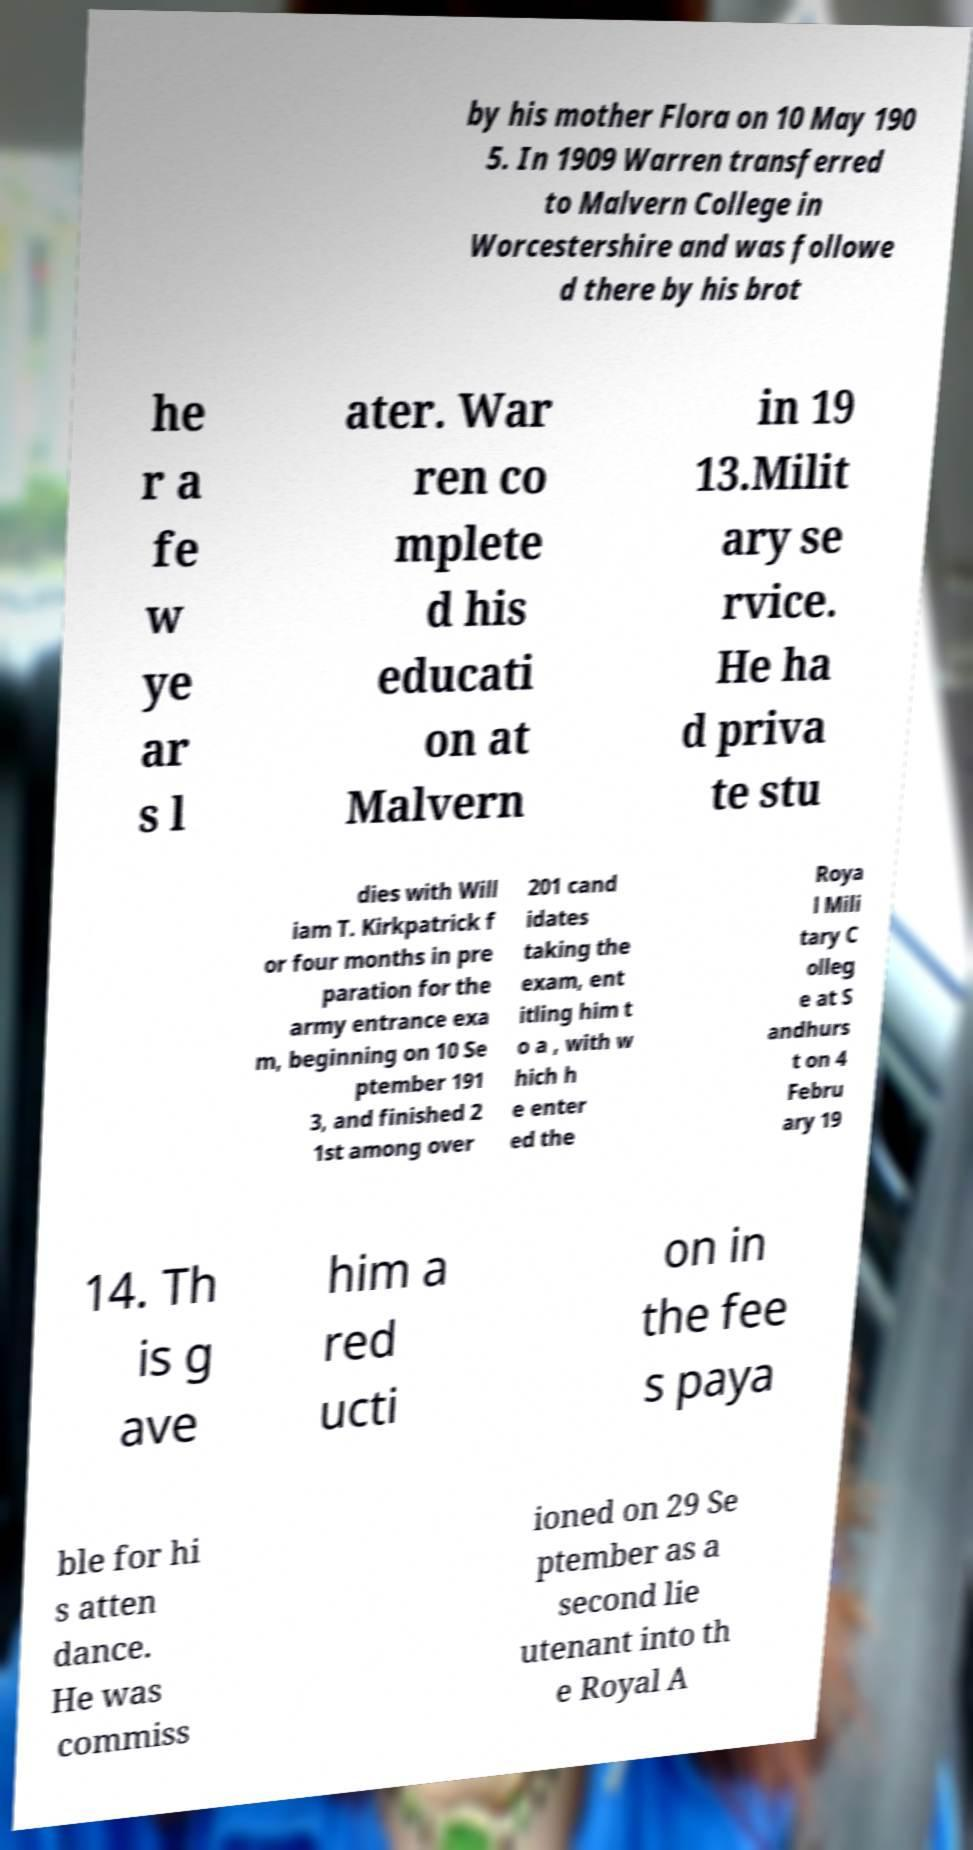There's text embedded in this image that I need extracted. Can you transcribe it verbatim? by his mother Flora on 10 May 190 5. In 1909 Warren transferred to Malvern College in Worcestershire and was followe d there by his brot he r a fe w ye ar s l ater. War ren co mplete d his educati on at Malvern in 19 13.Milit ary se rvice. He ha d priva te stu dies with Will iam T. Kirkpatrick f or four months in pre paration for the army entrance exa m, beginning on 10 Se ptember 191 3, and finished 2 1st among over 201 cand idates taking the exam, ent itling him t o a , with w hich h e enter ed the Roya l Mili tary C olleg e at S andhurs t on 4 Febru ary 19 14. Th is g ave him a red ucti on in the fee s paya ble for hi s atten dance. He was commiss ioned on 29 Se ptember as a second lie utenant into th e Royal A 